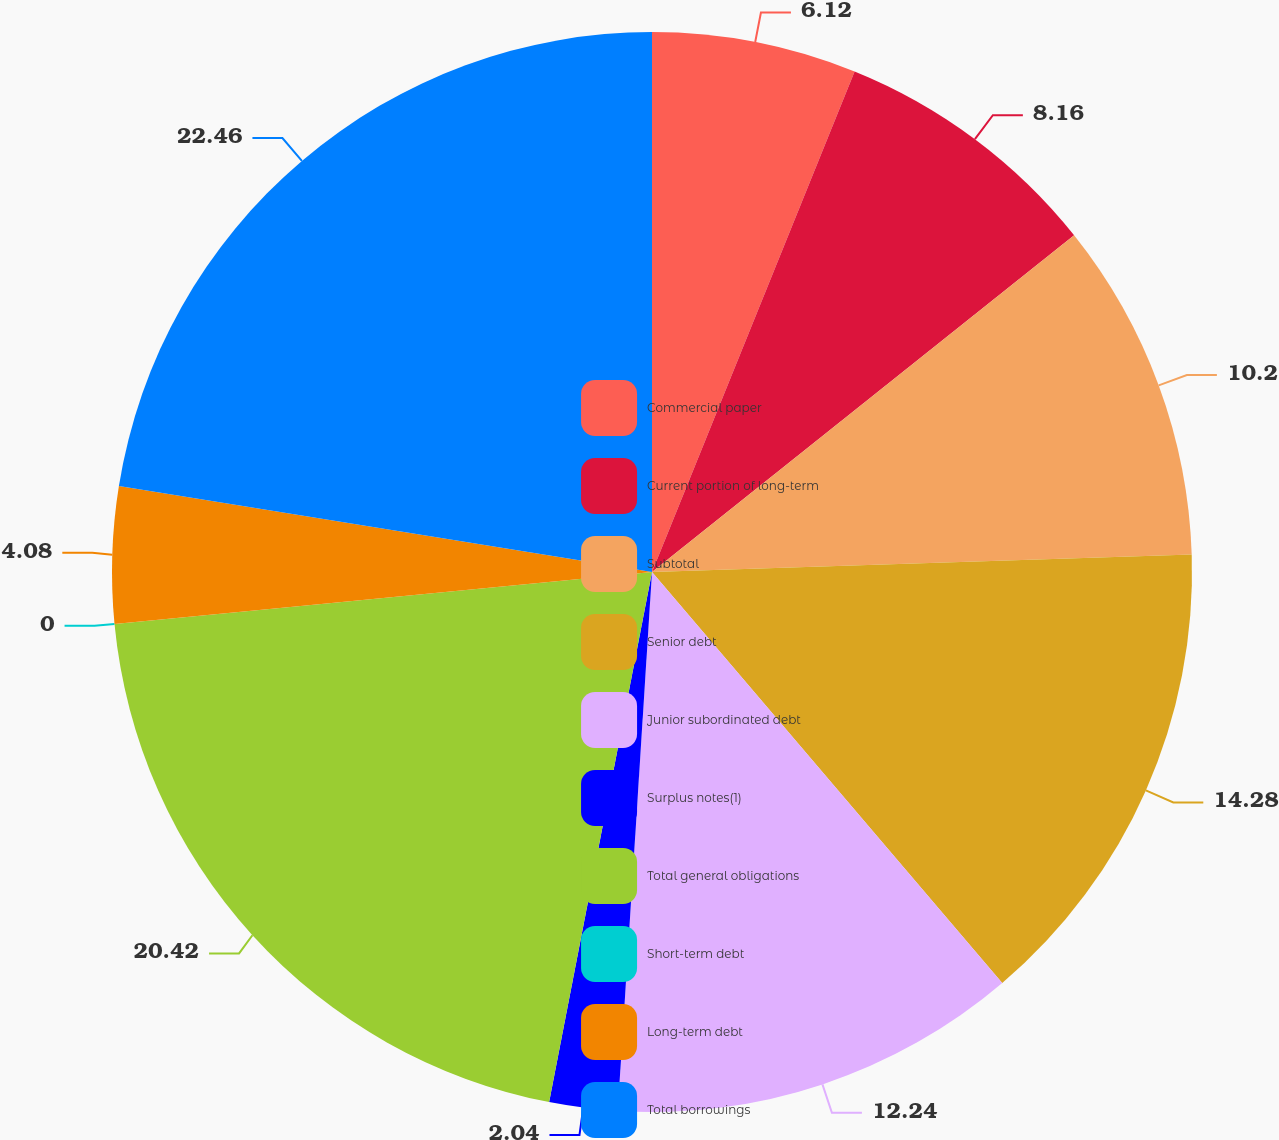<chart> <loc_0><loc_0><loc_500><loc_500><pie_chart><fcel>Commercial paper<fcel>Current portion of long-term<fcel>Subtotal<fcel>Senior debt<fcel>Junior subordinated debt<fcel>Surplus notes(1)<fcel>Total general obligations<fcel>Short-term debt<fcel>Long-term debt<fcel>Total borrowings<nl><fcel>6.12%<fcel>8.16%<fcel>10.2%<fcel>14.28%<fcel>12.24%<fcel>2.04%<fcel>20.41%<fcel>0.0%<fcel>4.08%<fcel>22.45%<nl></chart> 